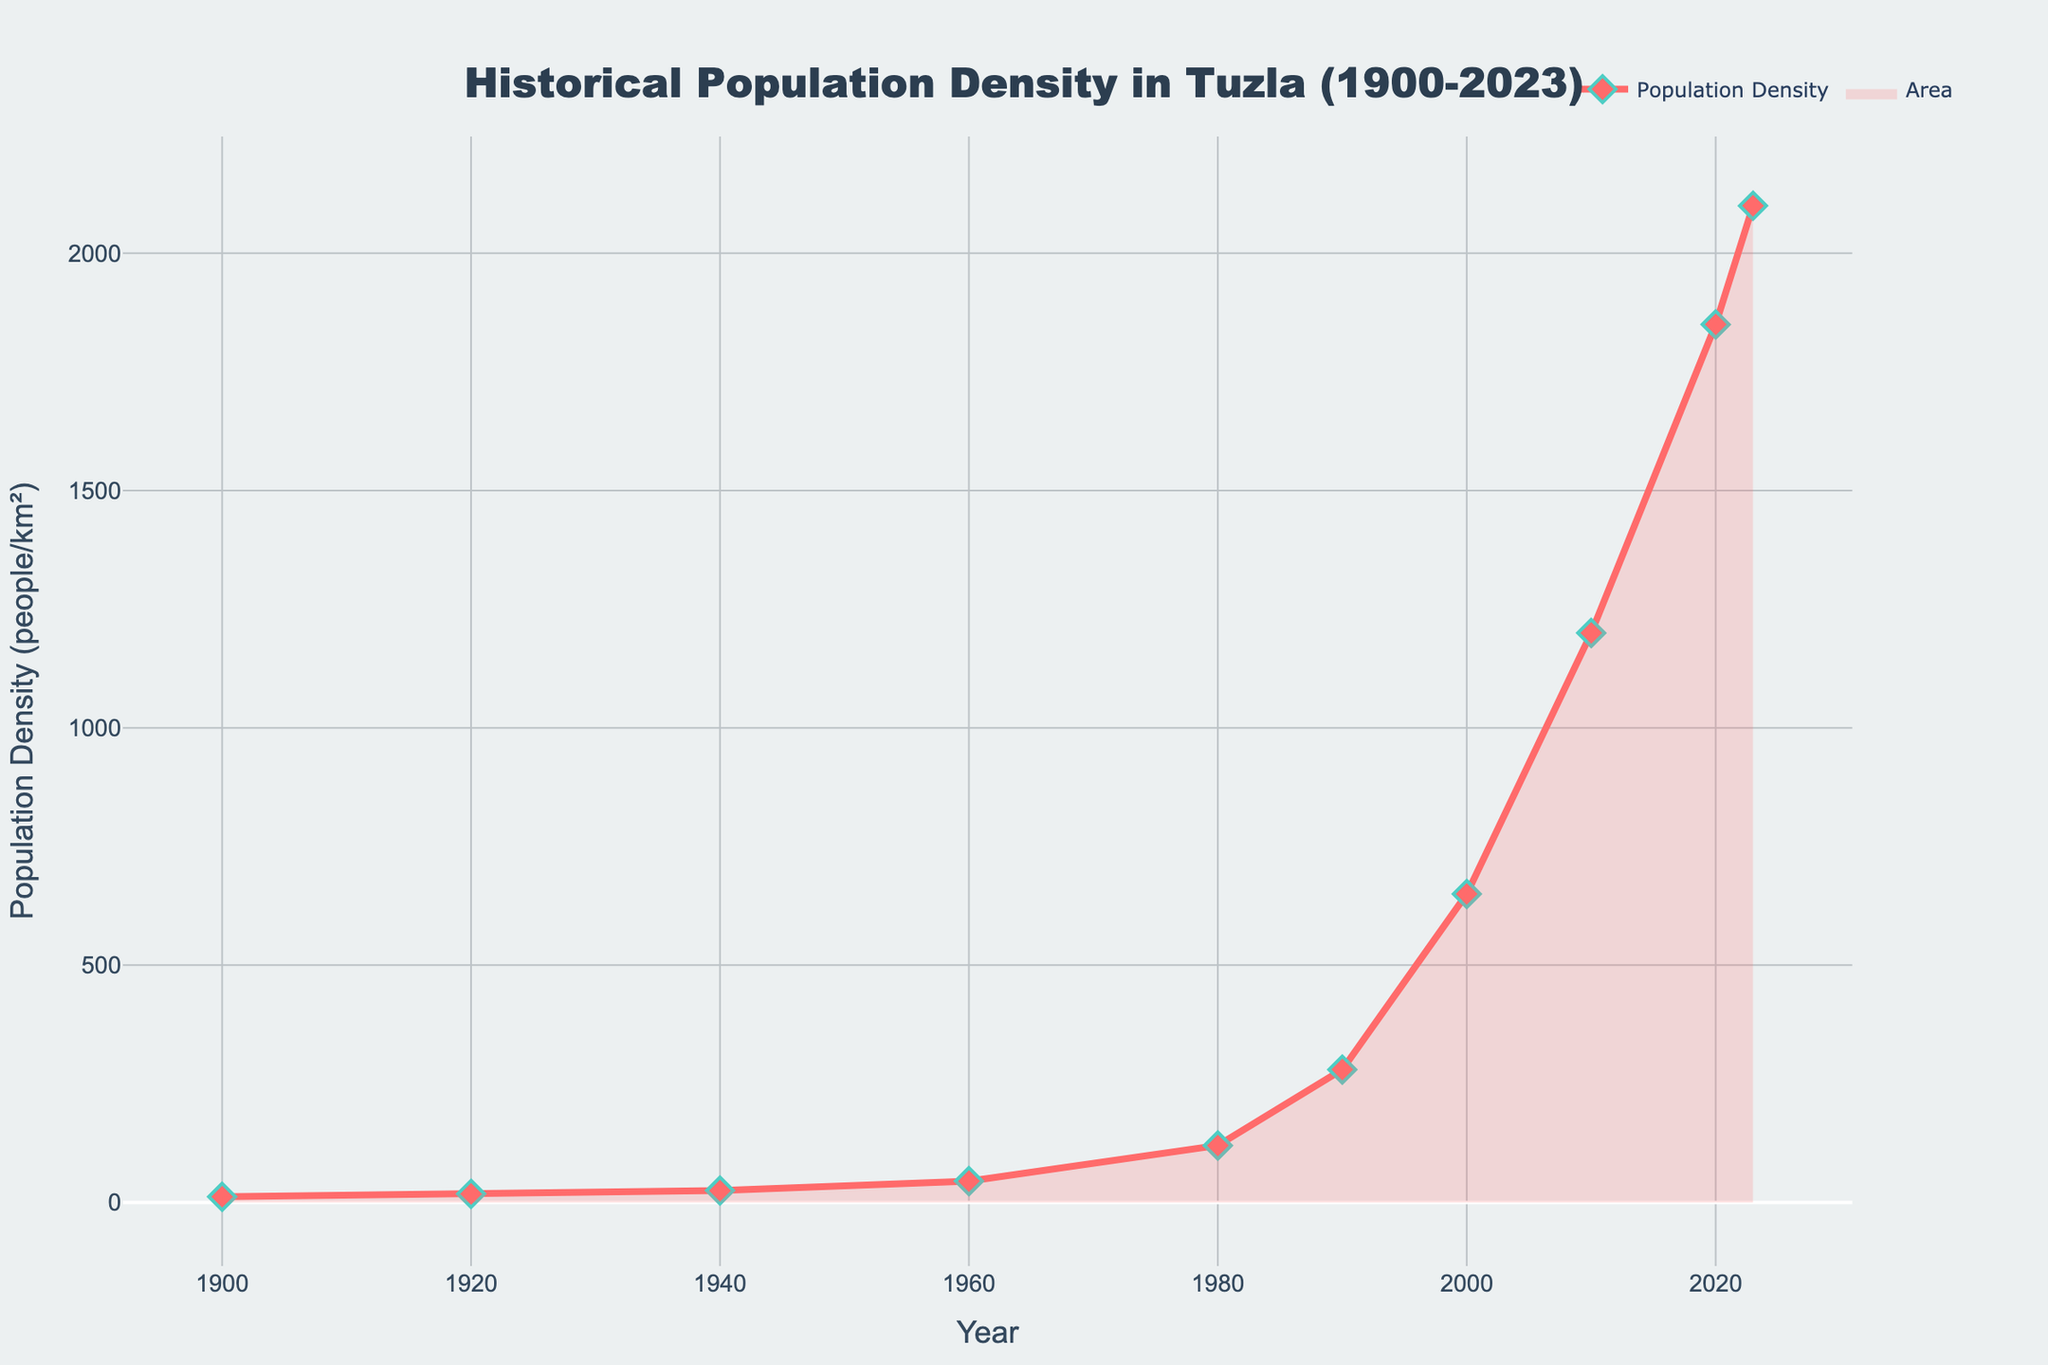What is the title of the figure? At the top of the figure, the title "Historical Population Density in Tuzla (1900-2023)" is clearly displayed.
Answer: Historical Population Density in Tuzla (1900-2023) What is the population density in the year 1900? By looking at the plot, you can see that the population density for the year 1900 is plotted at 12 people/km².
Answer: 12 people/km² Between which two consecutive periods did Tuzla experience the highest increase in population density? Look at the differences between consecutive points. The largest increase is between 2000 (650 people/km²) and 2010 (1200 people/km²), with an increase of 550 people/km².
Answer: 2000 to 2010 How many years are displayed on the x-axis? Counting the distinct years on the x-axis, there are 10 data points: 1900, 1920, 1940, 1960, 1980, 1990, 2000, 2010, 2020, and 2023.
Answer: 10 years Compare the population density between 1980 and 2000. Which year had a higher value? Checking the plot, the population density in 1980 was 120 people/km², and in 2000, it was 650 people/km². Thus, 2000 had a higher density.
Answer: 2000 What is the average population density from 1900 to 2023? Sum all the population density values: 12 + 18 + 25 + 45 + 120 + 280 + 650 + 1200 + 1850 + 2100 = 6300, then divide by the number of years (10). The average is 6300 / 10 = 630 people/km².
Answer: 630 people/km² What is the population density in 2023? By looking at the figure, you can observe that the population density in the year 2023 is marked at 2100 people/km².
Answer: 2100 people/km² During which decade did Tuzla's population density exceed 1000 people/km² for the first time? The plot indicates that by 2010, the population density was 1200 people/km², marking the first exceedance of 1000 people/km².
Answer: 2010 What can you infer about the general trend of population density in Tuzla from 1900 to 2023? Observing the plot, there is a clear upward trend indicating that population density in Tuzla has been increasing steadily over the years with sharper increases after 1960.
Answer: Increasing trend 